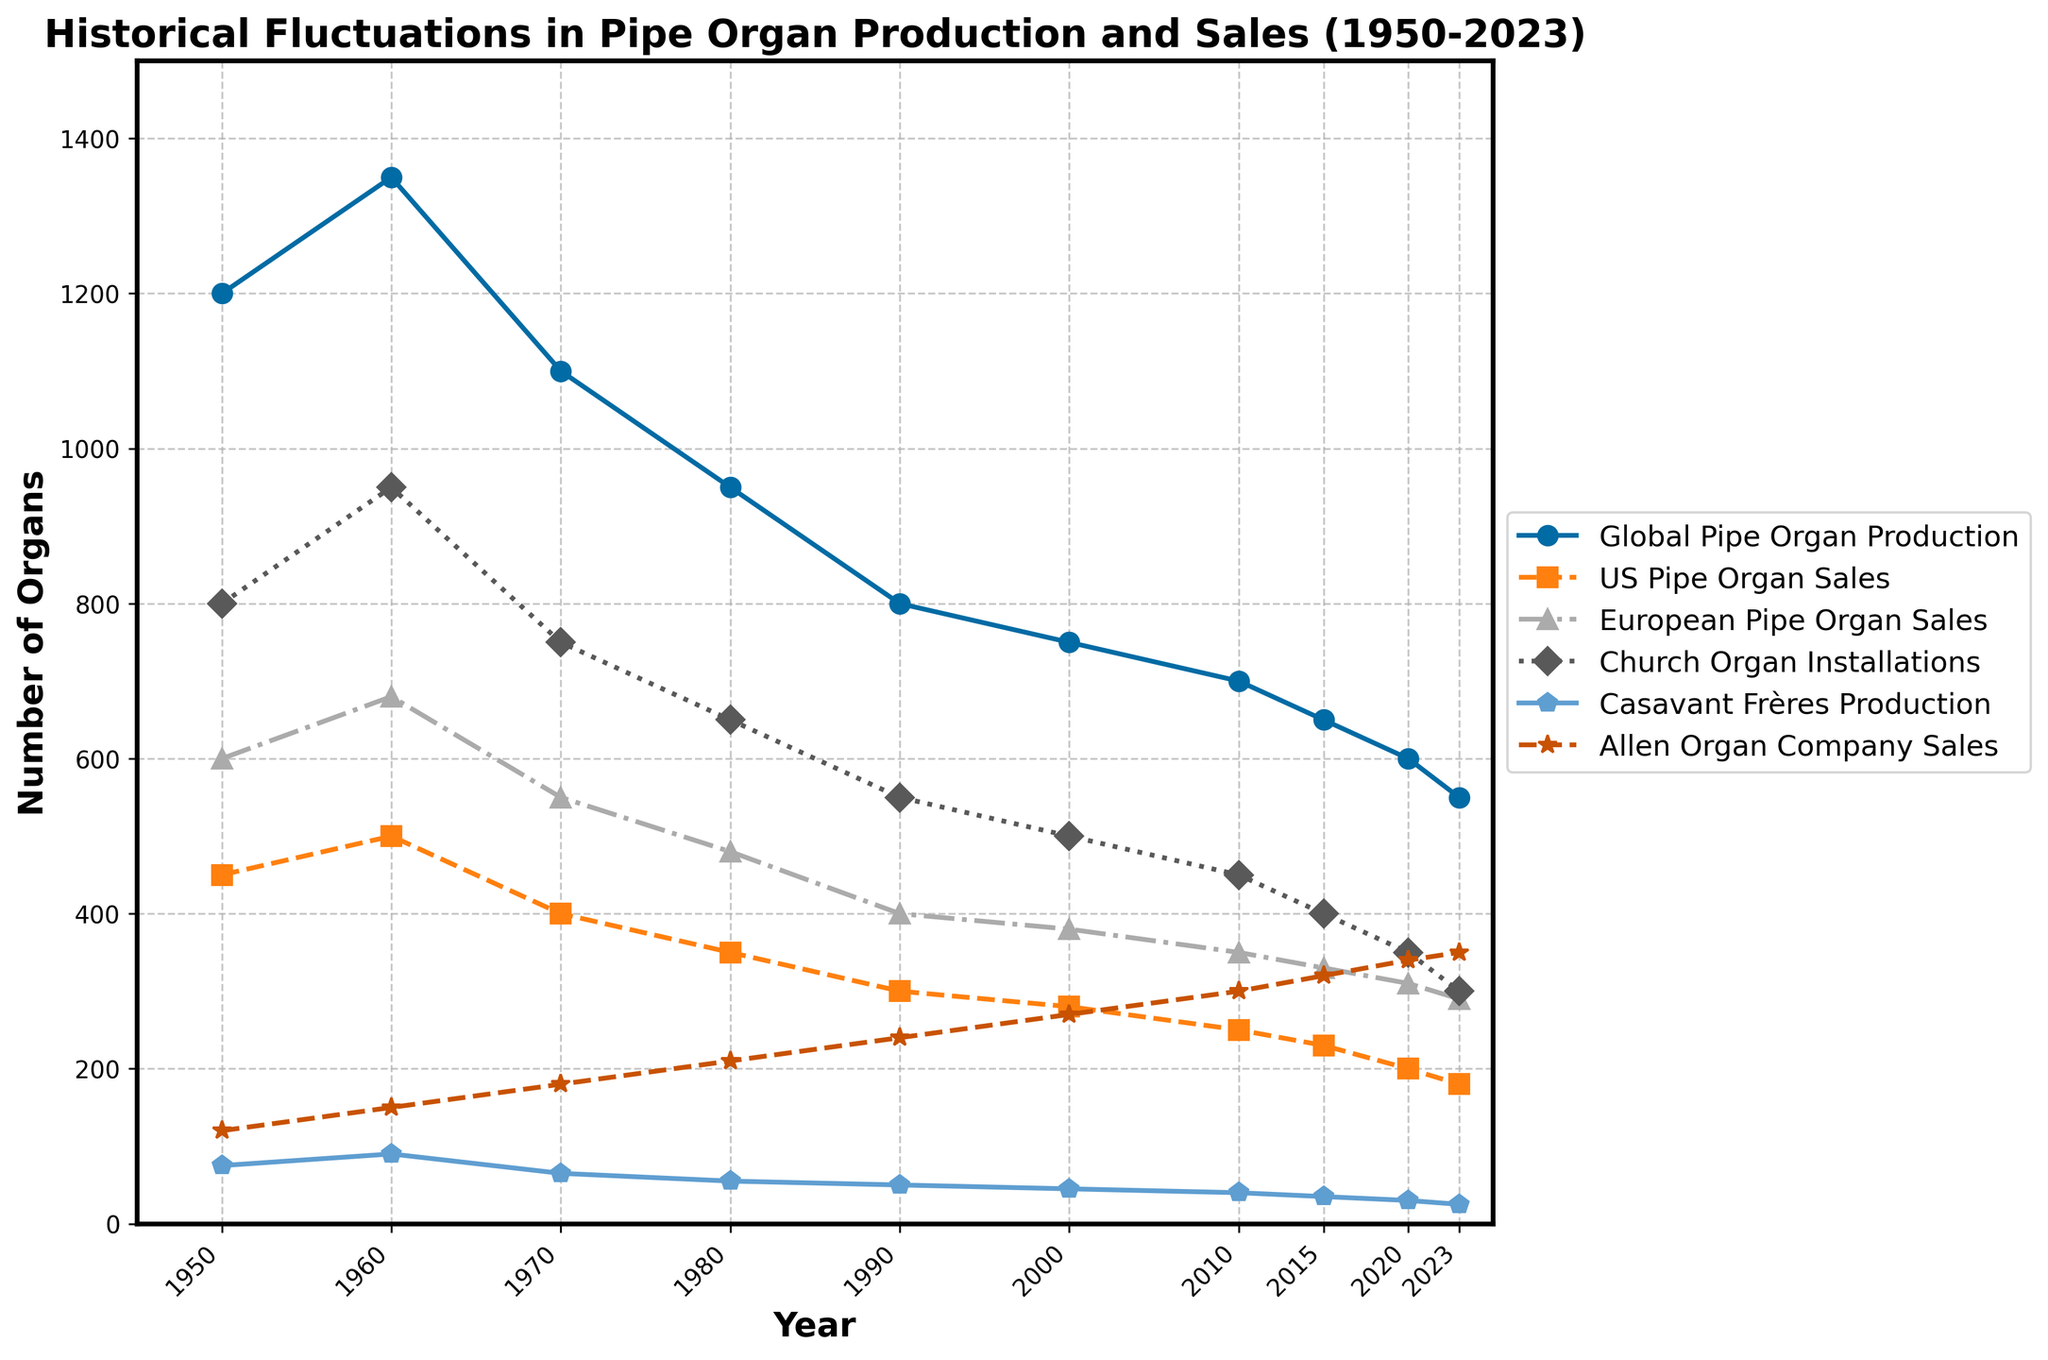Which category showed the highest number of sales or production in 1950? In 1950, the figures for all categories are visible. Global Pipe Organ Production is at 1200, which is the highest value compared to other categories for that year.
Answer: Global Pipe Organ Production Which company had increasing sales from 1950 to 2023, Allen or Casavant Frères? By visually following the line plots from 1950 to 2023, Allen Organ Company's sales trend is increasing, while Casavant Frères Production shows a decreasing trend.
Answer: Allen Organ Company What was the difference in Global Pipe Organ Production between 1950 and 2023? The Global Pipe Organ Production in 1950 is 1200 and in 2023 it is 550. The difference is 1200 - 550.
Answer: 650 How does the trend in Church Organ Installations compare to US Pipe Organ Sales? Church Organ Installations and US Pipe Organ Sales both show a decreasing trend from 1950 to 2023, but the decline in Church Organ Installations is more gradual.
Answer: Both decrease; Church Organ Installations drop more gradually What is the average number of European Pipe Organ Sales from 1950 to 2023? The values from 1950 to 2023 are 600, 680, 550, 480, 400, 380, 350, 330, 310, 290. Summing these gives 4370 and dividing by 10 gives the average.
Answer: 437 Which year had the highest number of Church Organ Installations? By inspecting the line that represents Church Organ Installations, 1960 shows the highest number at 950.
Answer: 1960 Did Casavant Frères or Allen Organ Company show a steadier trend in sales or production? Casavant Frères Production shows a consistent decrease, while Allen Organ Company shows a consistent increase, making both relatively constant trends.
Answer: Both steady but in opposite directions By how much did Allen Organ Company's sales increase from 1950 to 2023? Allen Organ Company's sales were 120 in 1950 and increased to 350 by 2023. The increase is 350 - 120.
Answer: 230 Which category experienced the sharpest decline from 1950 to 2023? Visually comparing the steepness of the slopes, Global Pipe Organ Production dropped from 1200 to 550, indicating the sharpest decline.
Answer: Global Pipe Organ Production Between 2000 and 2010, which category showed the least change? The values for 2000 and 2010 in each category reveal that Church Organ Installations dropped by 50, which is the smallest change.
Answer: Church Organ Installations 